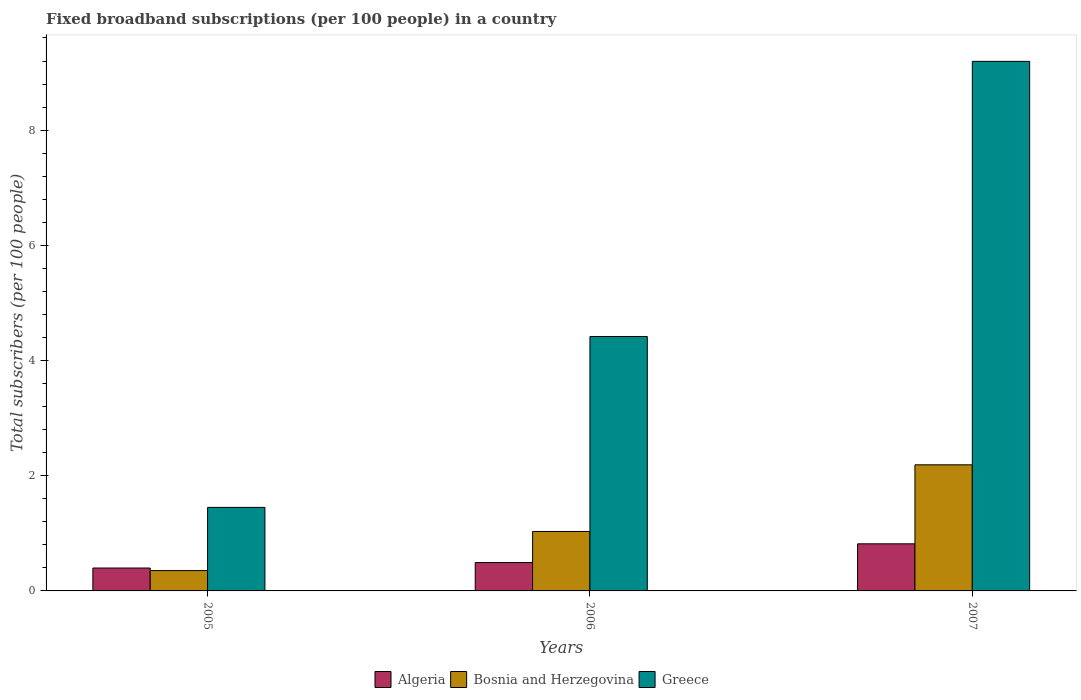How many groups of bars are there?
Provide a short and direct response. 3. How many bars are there on the 3rd tick from the right?
Your answer should be compact. 3. What is the number of broadband subscriptions in Greece in 2007?
Make the answer very short. 9.19. Across all years, what is the maximum number of broadband subscriptions in Bosnia and Herzegovina?
Provide a short and direct response. 2.19. Across all years, what is the minimum number of broadband subscriptions in Greece?
Offer a very short reply. 1.45. In which year was the number of broadband subscriptions in Algeria maximum?
Give a very brief answer. 2007. In which year was the number of broadband subscriptions in Algeria minimum?
Make the answer very short. 2005. What is the total number of broadband subscriptions in Greece in the graph?
Offer a very short reply. 15.06. What is the difference between the number of broadband subscriptions in Algeria in 2006 and that in 2007?
Your answer should be very brief. -0.33. What is the difference between the number of broadband subscriptions in Greece in 2007 and the number of broadband subscriptions in Bosnia and Herzegovina in 2005?
Give a very brief answer. 8.84. What is the average number of broadband subscriptions in Bosnia and Herzegovina per year?
Ensure brevity in your answer.  1.19. In the year 2006, what is the difference between the number of broadband subscriptions in Greece and number of broadband subscriptions in Bosnia and Herzegovina?
Give a very brief answer. 3.38. In how many years, is the number of broadband subscriptions in Greece greater than 0.8?
Your answer should be very brief. 3. What is the ratio of the number of broadband subscriptions in Greece in 2005 to that in 2007?
Offer a very short reply. 0.16. Is the number of broadband subscriptions in Bosnia and Herzegovina in 2005 less than that in 2006?
Your answer should be compact. Yes. What is the difference between the highest and the second highest number of broadband subscriptions in Bosnia and Herzegovina?
Keep it short and to the point. 1.16. What is the difference between the highest and the lowest number of broadband subscriptions in Bosnia and Herzegovina?
Make the answer very short. 1.84. In how many years, is the number of broadband subscriptions in Greece greater than the average number of broadband subscriptions in Greece taken over all years?
Provide a succinct answer. 1. What does the 1st bar from the left in 2005 represents?
Offer a very short reply. Algeria. What does the 3rd bar from the right in 2005 represents?
Give a very brief answer. Algeria. Is it the case that in every year, the sum of the number of broadband subscriptions in Algeria and number of broadband subscriptions in Bosnia and Herzegovina is greater than the number of broadband subscriptions in Greece?
Keep it short and to the point. No. Are all the bars in the graph horizontal?
Your response must be concise. No. How many years are there in the graph?
Offer a terse response. 3. What is the difference between two consecutive major ticks on the Y-axis?
Ensure brevity in your answer.  2. Does the graph contain grids?
Your response must be concise. No. How many legend labels are there?
Offer a very short reply. 3. What is the title of the graph?
Your answer should be very brief. Fixed broadband subscriptions (per 100 people) in a country. What is the label or title of the X-axis?
Your answer should be very brief. Years. What is the label or title of the Y-axis?
Your answer should be compact. Total subscribers (per 100 people). What is the Total subscribers (per 100 people) in Algeria in 2005?
Keep it short and to the point. 0.4. What is the Total subscribers (per 100 people) in Bosnia and Herzegovina in 2005?
Provide a short and direct response. 0.35. What is the Total subscribers (per 100 people) in Greece in 2005?
Offer a very short reply. 1.45. What is the Total subscribers (per 100 people) of Algeria in 2006?
Ensure brevity in your answer.  0.49. What is the Total subscribers (per 100 people) of Bosnia and Herzegovina in 2006?
Your response must be concise. 1.03. What is the Total subscribers (per 100 people) in Greece in 2006?
Make the answer very short. 4.42. What is the Total subscribers (per 100 people) in Algeria in 2007?
Your response must be concise. 0.82. What is the Total subscribers (per 100 people) of Bosnia and Herzegovina in 2007?
Give a very brief answer. 2.19. What is the Total subscribers (per 100 people) in Greece in 2007?
Provide a short and direct response. 9.19. Across all years, what is the maximum Total subscribers (per 100 people) of Algeria?
Provide a short and direct response. 0.82. Across all years, what is the maximum Total subscribers (per 100 people) in Bosnia and Herzegovina?
Keep it short and to the point. 2.19. Across all years, what is the maximum Total subscribers (per 100 people) of Greece?
Keep it short and to the point. 9.19. Across all years, what is the minimum Total subscribers (per 100 people) in Algeria?
Give a very brief answer. 0.4. Across all years, what is the minimum Total subscribers (per 100 people) of Bosnia and Herzegovina?
Keep it short and to the point. 0.35. Across all years, what is the minimum Total subscribers (per 100 people) in Greece?
Your answer should be very brief. 1.45. What is the total Total subscribers (per 100 people) in Algeria in the graph?
Your answer should be very brief. 1.71. What is the total Total subscribers (per 100 people) of Bosnia and Herzegovina in the graph?
Ensure brevity in your answer.  3.57. What is the total Total subscribers (per 100 people) in Greece in the graph?
Your answer should be compact. 15.06. What is the difference between the Total subscribers (per 100 people) of Algeria in 2005 and that in 2006?
Make the answer very short. -0.1. What is the difference between the Total subscribers (per 100 people) of Bosnia and Herzegovina in 2005 and that in 2006?
Your response must be concise. -0.68. What is the difference between the Total subscribers (per 100 people) of Greece in 2005 and that in 2006?
Give a very brief answer. -2.97. What is the difference between the Total subscribers (per 100 people) in Algeria in 2005 and that in 2007?
Give a very brief answer. -0.42. What is the difference between the Total subscribers (per 100 people) in Bosnia and Herzegovina in 2005 and that in 2007?
Give a very brief answer. -1.84. What is the difference between the Total subscribers (per 100 people) in Greece in 2005 and that in 2007?
Ensure brevity in your answer.  -7.74. What is the difference between the Total subscribers (per 100 people) in Algeria in 2006 and that in 2007?
Your response must be concise. -0.33. What is the difference between the Total subscribers (per 100 people) in Bosnia and Herzegovina in 2006 and that in 2007?
Your response must be concise. -1.16. What is the difference between the Total subscribers (per 100 people) of Greece in 2006 and that in 2007?
Provide a succinct answer. -4.78. What is the difference between the Total subscribers (per 100 people) in Algeria in 2005 and the Total subscribers (per 100 people) in Bosnia and Herzegovina in 2006?
Ensure brevity in your answer.  -0.63. What is the difference between the Total subscribers (per 100 people) in Algeria in 2005 and the Total subscribers (per 100 people) in Greece in 2006?
Your answer should be compact. -4.02. What is the difference between the Total subscribers (per 100 people) of Bosnia and Herzegovina in 2005 and the Total subscribers (per 100 people) of Greece in 2006?
Provide a short and direct response. -4.06. What is the difference between the Total subscribers (per 100 people) in Algeria in 2005 and the Total subscribers (per 100 people) in Bosnia and Herzegovina in 2007?
Provide a short and direct response. -1.79. What is the difference between the Total subscribers (per 100 people) in Algeria in 2005 and the Total subscribers (per 100 people) in Greece in 2007?
Ensure brevity in your answer.  -8.8. What is the difference between the Total subscribers (per 100 people) in Bosnia and Herzegovina in 2005 and the Total subscribers (per 100 people) in Greece in 2007?
Give a very brief answer. -8.84. What is the difference between the Total subscribers (per 100 people) of Algeria in 2006 and the Total subscribers (per 100 people) of Bosnia and Herzegovina in 2007?
Ensure brevity in your answer.  -1.7. What is the difference between the Total subscribers (per 100 people) of Algeria in 2006 and the Total subscribers (per 100 people) of Greece in 2007?
Provide a short and direct response. -8.7. What is the difference between the Total subscribers (per 100 people) in Bosnia and Herzegovina in 2006 and the Total subscribers (per 100 people) in Greece in 2007?
Offer a very short reply. -8.16. What is the average Total subscribers (per 100 people) of Algeria per year?
Your answer should be compact. 0.57. What is the average Total subscribers (per 100 people) of Bosnia and Herzegovina per year?
Your answer should be very brief. 1.19. What is the average Total subscribers (per 100 people) in Greece per year?
Give a very brief answer. 5.02. In the year 2005, what is the difference between the Total subscribers (per 100 people) of Algeria and Total subscribers (per 100 people) of Bosnia and Herzegovina?
Provide a succinct answer. 0.04. In the year 2005, what is the difference between the Total subscribers (per 100 people) of Algeria and Total subscribers (per 100 people) of Greece?
Provide a short and direct response. -1.05. In the year 2005, what is the difference between the Total subscribers (per 100 people) of Bosnia and Herzegovina and Total subscribers (per 100 people) of Greece?
Your answer should be compact. -1.1. In the year 2006, what is the difference between the Total subscribers (per 100 people) in Algeria and Total subscribers (per 100 people) in Bosnia and Herzegovina?
Offer a terse response. -0.54. In the year 2006, what is the difference between the Total subscribers (per 100 people) in Algeria and Total subscribers (per 100 people) in Greece?
Your answer should be very brief. -3.92. In the year 2006, what is the difference between the Total subscribers (per 100 people) of Bosnia and Herzegovina and Total subscribers (per 100 people) of Greece?
Provide a short and direct response. -3.38. In the year 2007, what is the difference between the Total subscribers (per 100 people) of Algeria and Total subscribers (per 100 people) of Bosnia and Herzegovina?
Provide a succinct answer. -1.37. In the year 2007, what is the difference between the Total subscribers (per 100 people) of Algeria and Total subscribers (per 100 people) of Greece?
Offer a very short reply. -8.38. In the year 2007, what is the difference between the Total subscribers (per 100 people) of Bosnia and Herzegovina and Total subscribers (per 100 people) of Greece?
Give a very brief answer. -7. What is the ratio of the Total subscribers (per 100 people) in Algeria in 2005 to that in 2006?
Give a very brief answer. 0.81. What is the ratio of the Total subscribers (per 100 people) in Bosnia and Herzegovina in 2005 to that in 2006?
Make the answer very short. 0.34. What is the ratio of the Total subscribers (per 100 people) of Greece in 2005 to that in 2006?
Give a very brief answer. 0.33. What is the ratio of the Total subscribers (per 100 people) of Algeria in 2005 to that in 2007?
Ensure brevity in your answer.  0.49. What is the ratio of the Total subscribers (per 100 people) in Bosnia and Herzegovina in 2005 to that in 2007?
Offer a very short reply. 0.16. What is the ratio of the Total subscribers (per 100 people) in Greece in 2005 to that in 2007?
Give a very brief answer. 0.16. What is the ratio of the Total subscribers (per 100 people) in Algeria in 2006 to that in 2007?
Provide a short and direct response. 0.6. What is the ratio of the Total subscribers (per 100 people) in Bosnia and Herzegovina in 2006 to that in 2007?
Make the answer very short. 0.47. What is the ratio of the Total subscribers (per 100 people) in Greece in 2006 to that in 2007?
Provide a succinct answer. 0.48. What is the difference between the highest and the second highest Total subscribers (per 100 people) of Algeria?
Ensure brevity in your answer.  0.33. What is the difference between the highest and the second highest Total subscribers (per 100 people) of Bosnia and Herzegovina?
Give a very brief answer. 1.16. What is the difference between the highest and the second highest Total subscribers (per 100 people) in Greece?
Ensure brevity in your answer.  4.78. What is the difference between the highest and the lowest Total subscribers (per 100 people) of Algeria?
Your answer should be very brief. 0.42. What is the difference between the highest and the lowest Total subscribers (per 100 people) of Bosnia and Herzegovina?
Your response must be concise. 1.84. What is the difference between the highest and the lowest Total subscribers (per 100 people) of Greece?
Make the answer very short. 7.74. 